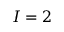Convert formula to latex. <formula><loc_0><loc_0><loc_500><loc_500>I = 2</formula> 